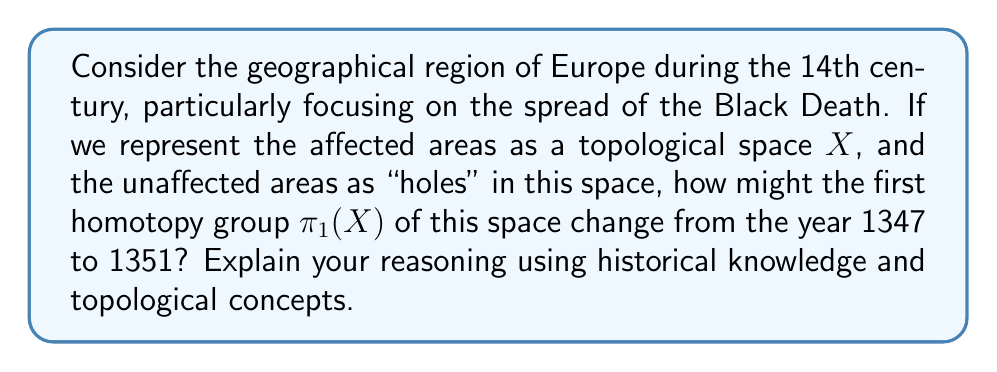Provide a solution to this math problem. To approach this problem, we need to combine our understanding of topology with historical knowledge of the Black Death's spread in Europe:

1) The first homotopy group $\pi_1(X)$ represents the fundamental group of a topological space $X$. It captures the essence of 1-dimensional holes in the space.

2) In 1347, the Black Death had just begun to spread in Europe, primarily affecting coastal regions and major trade routes. The affected areas would form a relatively simple connected region, with many "holes" representing unaffected inland areas.

3) At this stage, the topological space $X$ might resemble a thick, irregular ring around the coastlines of Europe. The first homotopy group $\pi_1(X)$ would be non-trivial, possibly isomorphic to $\mathbb{Z}$, representing the ability to create loops around the large "hole" of unaffected central Europe.

4) As the plague spread inland from 1347 to 1351, it would gradually fill in many of these "holes". The topology of $X$ would become more complex, with smaller, isolated unaffected regions.

5) By 1351, most of Europe had been affected by the Black Death. The topological space $X$ would now cover most of Europe, with only small, scattered "holes" representing the few unaffected areas.

6) This change in the space's structure would significantly alter its first homotopy group. As the large central "hole" filled in, the ability to form non-contractible loops around it would diminish.

7) The first homotopy group $\pi_1(X)$ would likely transition from being isomorphic to $\mathbb{Z}$ (or a small number of $\mathbb{Z}$ factors) to a more complex group structure, potentially becoming trivial if all significant "holes" were filled.

Therefore, we can conclude that the first homotopy group $\pi_1(X)$ would likely change from a relatively simple non-trivial group (possibly $\mathbb{Z}$ or $\mathbb{Z}^n$ for small $n$) in 1347 to a more complex group or potentially the trivial group by 1351, reflecting the widespread nature of the Black Death's impact across Europe.
Answer: The first homotopy group $\pi_1(X)$ would likely change from $\mathbb{Z}$ or $\mathbb{Z}^n$ (for small $n$) in 1347 to a more complex group or potentially the trivial group $\{e\}$ by 1351. 